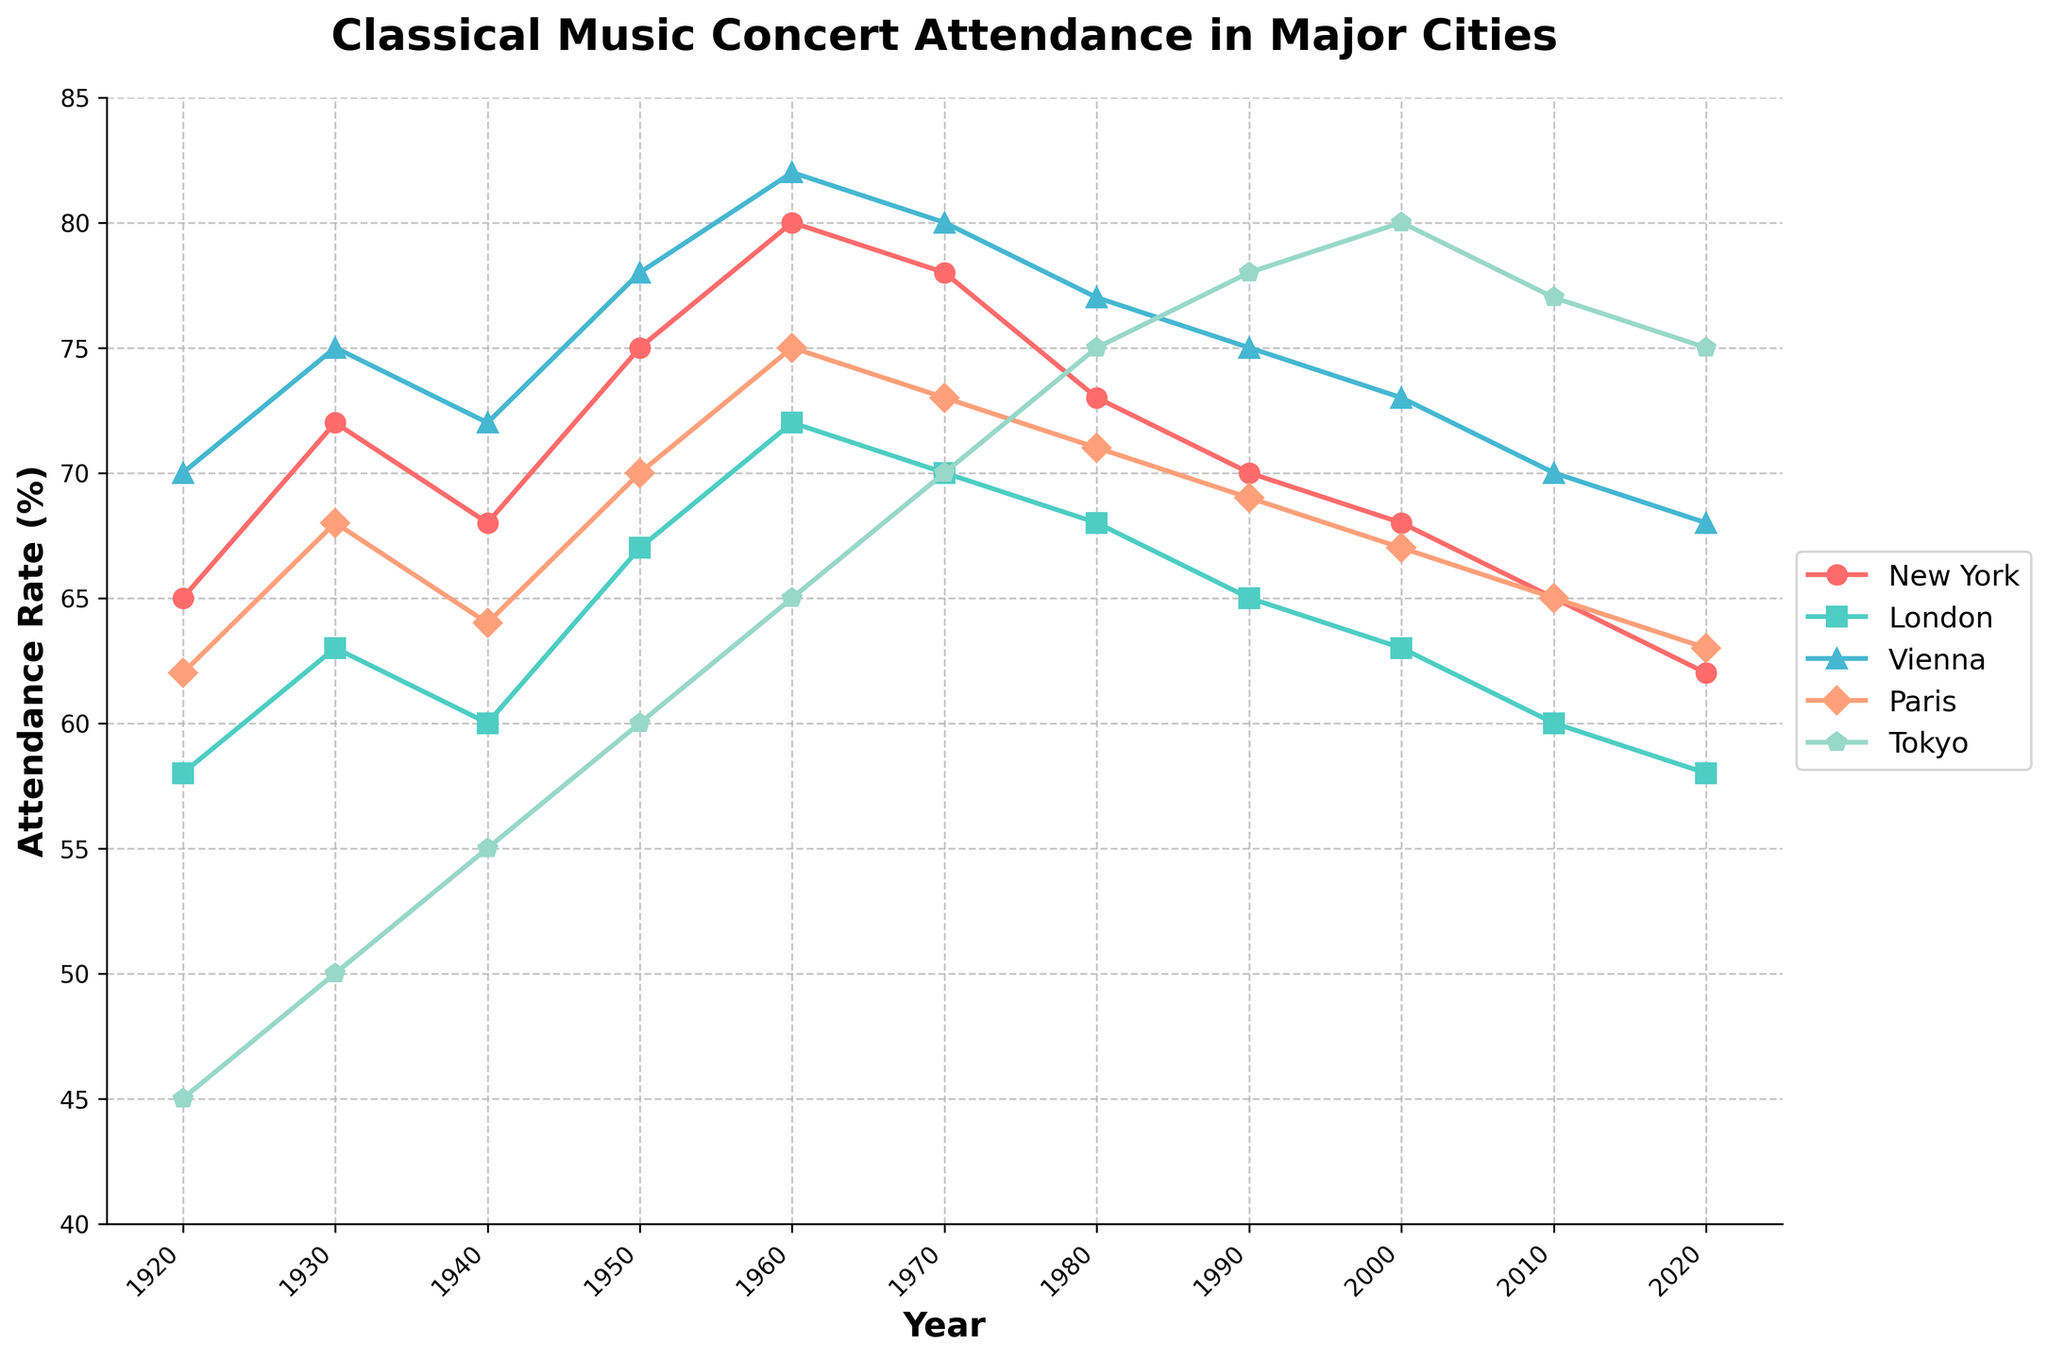What was the attendance rate in New York in 1950? Find the year 1950 on the x-axis and look at the corresponding point for New York on the plot. The attendance rate for New York in 1950 was 75%.
Answer: 75% Compare the attendance rates in New York and Tokyo in 2010. Which city had higher attendance? Locate the year 2010 on the x-axis and look at the respective positions of New York and Tokyo. New York’s attendance rate was 65%, while Tokyo’s was 77%. Therefore, Tokyo had a higher attendance rate in 2010.
Answer: Tokyo What is the trend of attendance rates in Vienna from 1920 to 2020? Examine the Vienna line (the line specific to Vienna) over the years 1920 to 2020. The attendance rate starts at 70%, peaks around the 1960s-1970s, and then slightly declines towards 68% by 2020. The trend shows an overall increase until the 1970s, followed by a slight decrease.
Answer: Overall increasing until the 1970s, slight decrease afterward Which city experienced the highest attendance rate in 1960? Look at all the data points across different cities for the year 1960. Vienna had the highest attendance rate at 82%.
Answer: Vienna Calculate the average attendance rate for London from 1920 to 2020. Sum up all the attendance rates for London from 1920 to 2020 (58 + 63 + 60 + 67 + 72 + 70 + 68 + 65 + 63 + 60 + 58), which equals 704. There are 11 data points, so the average is 704 / 11 = 64%.
Answer: 64% Did any city show a decreasing attendance rate trend from 1920 to 2020? Look at each city's line from 1920 to 2020 and identify if the line generally trends downward. New York, London, and Paris show a general decreasing trend over the century.
Answer: New York, London, Paris Between Paris and Vienna, which city had a more consistent attendance rate from 1920 to 2020? Compare the variation in the lines representing Paris and Vienna. Paris shows more fluctuations compared to Vienna, which has a relatively steadier line.
Answer: Vienna By how much did Tokyo's attendance rate change from 1920 to 2020? Find the attendance rates for Tokyo in 1920 and 2020 (45% and 75%, respectively). Calculate the difference: 75% - 45% = 30%.
Answer: 30% What can you infer about the global trend in classical music concert attendance by observing the overall plot? Look at the general direction of all lines together. Initially, there is an upward trend reaching around the 1960s-1970s, after which there's a visible decline or stagnation in most cities. This indicates that global attendance peaked mid-century and has been generally decreasing or stable since.
Answer: Peaked mid-century, then declined/stagnated 